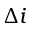<formula> <loc_0><loc_0><loc_500><loc_500>\Delta i</formula> 